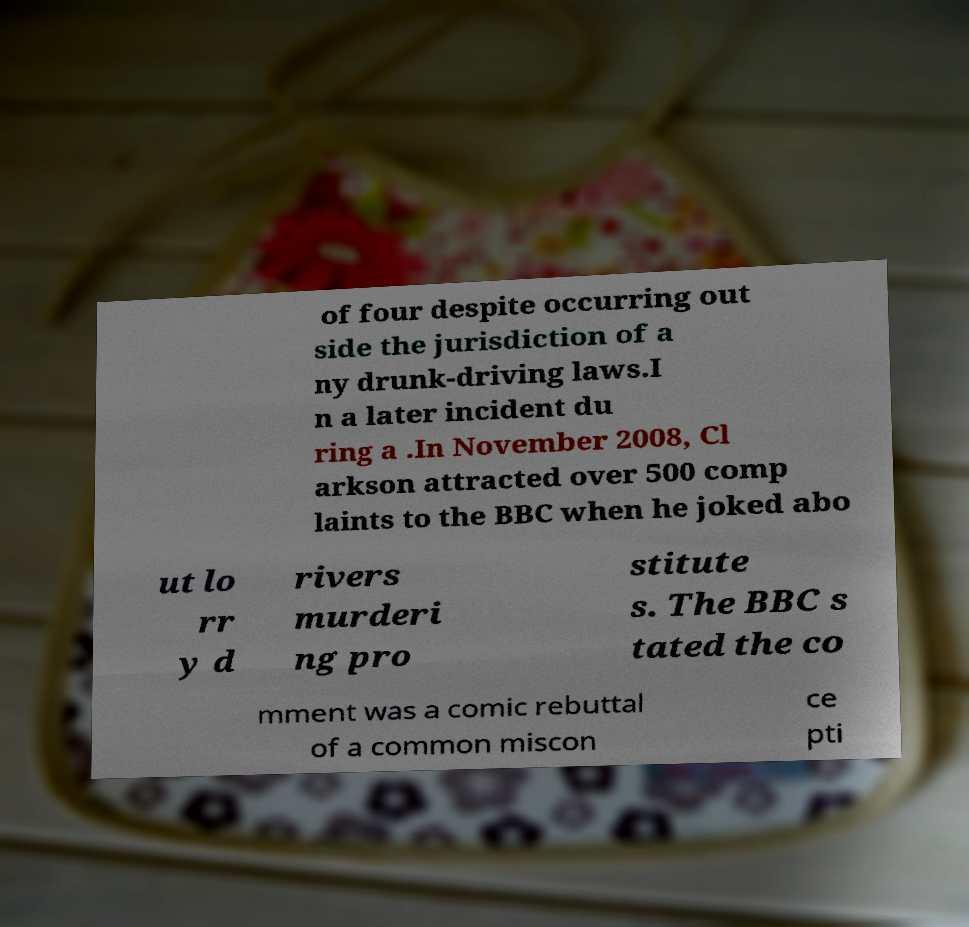Can you read and provide the text displayed in the image?This photo seems to have some interesting text. Can you extract and type it out for me? of four despite occurring out side the jurisdiction of a ny drunk-driving laws.I n a later incident du ring a .In November 2008, Cl arkson attracted over 500 comp laints to the BBC when he joked abo ut lo rr y d rivers murderi ng pro stitute s. The BBC s tated the co mment was a comic rebuttal of a common miscon ce pti 